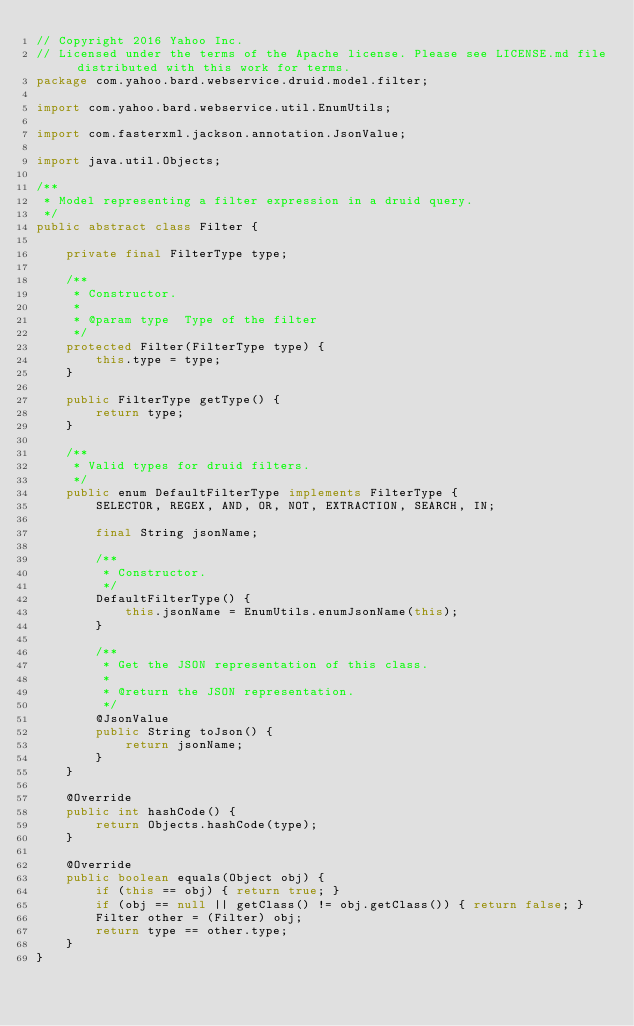<code> <loc_0><loc_0><loc_500><loc_500><_Java_>// Copyright 2016 Yahoo Inc.
// Licensed under the terms of the Apache license. Please see LICENSE.md file distributed with this work for terms.
package com.yahoo.bard.webservice.druid.model.filter;

import com.yahoo.bard.webservice.util.EnumUtils;

import com.fasterxml.jackson.annotation.JsonValue;

import java.util.Objects;

/**
 * Model representing a filter expression in a druid query.
 */
public abstract class Filter {

    private final FilterType type;

    /**
     * Constructor.
     *
     * @param type  Type of the filter
     */
    protected Filter(FilterType type) {
        this.type = type;
    }

    public FilterType getType() {
        return type;
    }

    /**
     * Valid types for druid filters.
     */
    public enum DefaultFilterType implements FilterType {
        SELECTOR, REGEX, AND, OR, NOT, EXTRACTION, SEARCH, IN;

        final String jsonName;

        /**
         * Constructor.
         */
        DefaultFilterType() {
            this.jsonName = EnumUtils.enumJsonName(this);
        }

        /**
         * Get the JSON representation of this class.
         *
         * @return the JSON representation.
         */
        @JsonValue
        public String toJson() {
            return jsonName;
        }
    }

    @Override
    public int hashCode() {
        return Objects.hashCode(type);
    }

    @Override
    public boolean equals(Object obj) {
        if (this == obj) { return true; }
        if (obj == null || getClass() != obj.getClass()) { return false; }
        Filter other = (Filter) obj;
        return type == other.type;
    }
}
</code> 